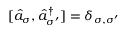<formula> <loc_0><loc_0><loc_500><loc_500>[ \hat { a } _ { \sigma } , \hat { a } _ { \sigma ^ { \prime } } ^ { \dagger } ] = \delta _ { \sigma , \sigma ^ { \prime } }</formula> 